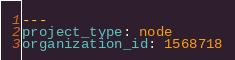Convert code to text. <code><loc_0><loc_0><loc_500><loc_500><_YAML_>---
project_type: node
organization_id: 1568718
</code> 